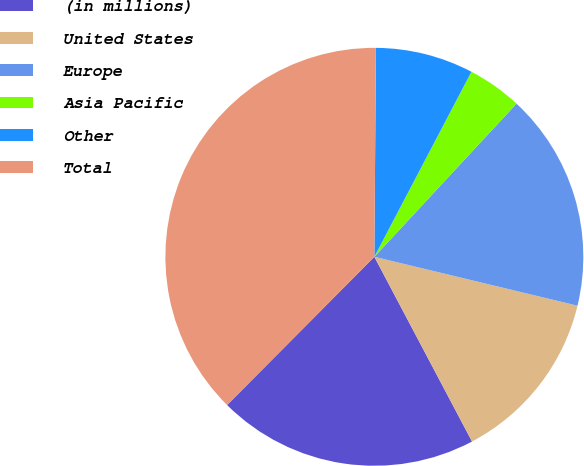<chart> <loc_0><loc_0><loc_500><loc_500><pie_chart><fcel>(in millions)<fcel>United States<fcel>Europe<fcel>Asia Pacific<fcel>Other<fcel>Total<nl><fcel>20.19%<fcel>13.5%<fcel>16.85%<fcel>4.22%<fcel>7.57%<fcel>37.67%<nl></chart> 